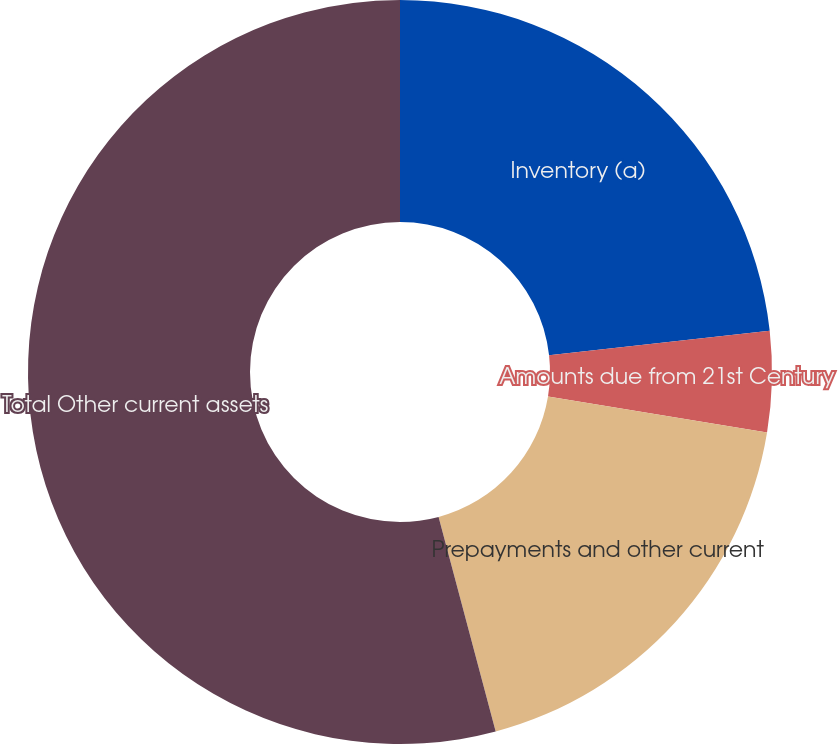Convert chart to OTSL. <chart><loc_0><loc_0><loc_500><loc_500><pie_chart><fcel>Inventory (a)<fcel>Amounts due from 21st Century<fcel>Prepayments and other current<fcel>Total Other current assets<nl><fcel>23.23%<fcel>4.37%<fcel>18.26%<fcel>54.14%<nl></chart> 